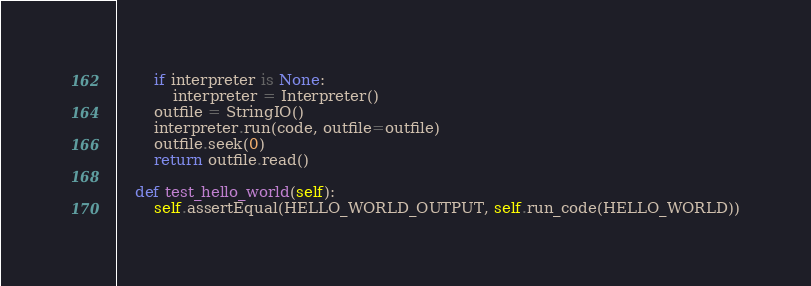Convert code to text. <code><loc_0><loc_0><loc_500><loc_500><_Python_>        if interpreter is None:
            interpreter = Interpreter()
        outfile = StringIO()
        interpreter.run(code, outfile=outfile)
        outfile.seek(0)
        return outfile.read()

    def test_hello_world(self):
        self.assertEqual(HELLO_WORLD_OUTPUT, self.run_code(HELLO_WORLD))
</code> 